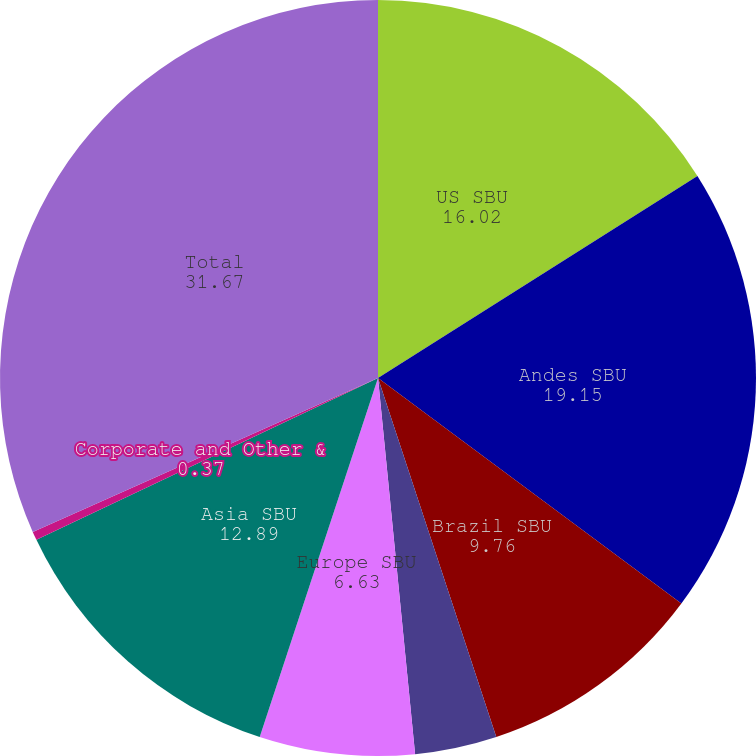<chart> <loc_0><loc_0><loc_500><loc_500><pie_chart><fcel>US SBU<fcel>Andes SBU<fcel>Brazil SBU<fcel>MCAC SBU<fcel>Europe SBU<fcel>Asia SBU<fcel>Corporate and Other &<fcel>Total<nl><fcel>16.02%<fcel>19.15%<fcel>9.76%<fcel>3.5%<fcel>6.63%<fcel>12.89%<fcel>0.37%<fcel>31.67%<nl></chart> 